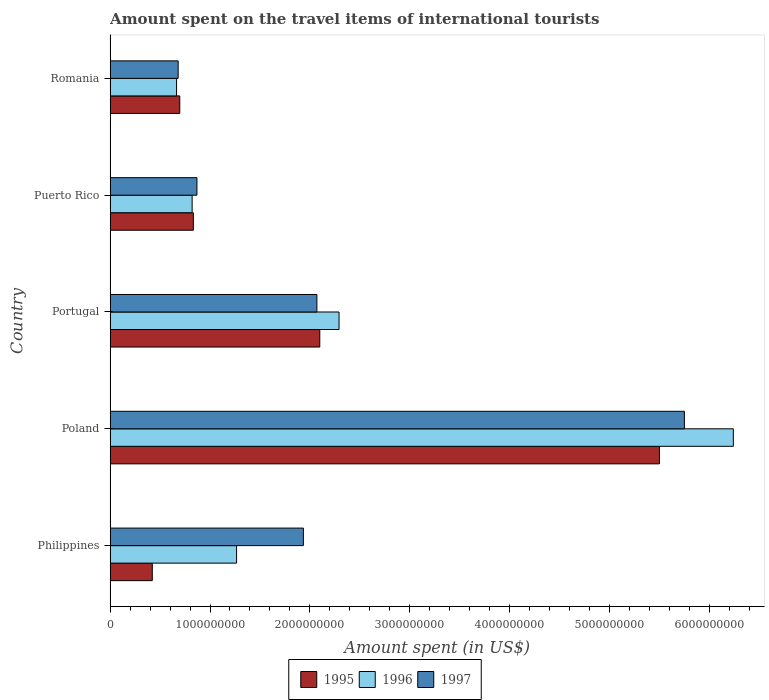How many different coloured bars are there?
Provide a succinct answer. 3. How many bars are there on the 5th tick from the top?
Your answer should be compact. 3. How many bars are there on the 3rd tick from the bottom?
Offer a very short reply. 3. In how many cases, is the number of bars for a given country not equal to the number of legend labels?
Give a very brief answer. 0. What is the amount spent on the travel items of international tourists in 1997 in Philippines?
Give a very brief answer. 1.94e+09. Across all countries, what is the maximum amount spent on the travel items of international tourists in 1997?
Offer a very short reply. 5.75e+09. Across all countries, what is the minimum amount spent on the travel items of international tourists in 1995?
Ensure brevity in your answer.  4.22e+08. In which country was the amount spent on the travel items of international tourists in 1995 maximum?
Make the answer very short. Poland. In which country was the amount spent on the travel items of international tourists in 1997 minimum?
Keep it short and to the point. Romania. What is the total amount spent on the travel items of international tourists in 1997 in the graph?
Ensure brevity in your answer.  1.13e+1. What is the difference between the amount spent on the travel items of international tourists in 1996 in Portugal and that in Romania?
Provide a short and direct response. 1.63e+09. What is the difference between the amount spent on the travel items of international tourists in 1995 in Romania and the amount spent on the travel items of international tourists in 1996 in Philippines?
Ensure brevity in your answer.  -5.69e+08. What is the average amount spent on the travel items of international tourists in 1996 per country?
Offer a very short reply. 2.26e+09. What is the difference between the amount spent on the travel items of international tourists in 1995 and amount spent on the travel items of international tourists in 1997 in Portugal?
Ensure brevity in your answer.  2.90e+07. What is the ratio of the amount spent on the travel items of international tourists in 1995 in Poland to that in Puerto Rico?
Offer a terse response. 6.6. Is the difference between the amount spent on the travel items of international tourists in 1995 in Portugal and Puerto Rico greater than the difference between the amount spent on the travel items of international tourists in 1997 in Portugal and Puerto Rico?
Ensure brevity in your answer.  Yes. What is the difference between the highest and the second highest amount spent on the travel items of international tourists in 1996?
Offer a very short reply. 3.95e+09. What is the difference between the highest and the lowest amount spent on the travel items of international tourists in 1995?
Keep it short and to the point. 5.08e+09. In how many countries, is the amount spent on the travel items of international tourists in 1997 greater than the average amount spent on the travel items of international tourists in 1997 taken over all countries?
Offer a terse response. 1. How many bars are there?
Ensure brevity in your answer.  15. Are all the bars in the graph horizontal?
Your response must be concise. Yes. Does the graph contain any zero values?
Offer a very short reply. No. Does the graph contain grids?
Your answer should be very brief. No. Where does the legend appear in the graph?
Offer a terse response. Bottom center. How many legend labels are there?
Your answer should be compact. 3. How are the legend labels stacked?
Offer a very short reply. Horizontal. What is the title of the graph?
Ensure brevity in your answer.  Amount spent on the travel items of international tourists. Does "2000" appear as one of the legend labels in the graph?
Your answer should be very brief. No. What is the label or title of the X-axis?
Offer a terse response. Amount spent (in US$). What is the label or title of the Y-axis?
Your answer should be very brief. Country. What is the Amount spent (in US$) of 1995 in Philippines?
Provide a short and direct response. 4.22e+08. What is the Amount spent (in US$) of 1996 in Philippines?
Keep it short and to the point. 1.27e+09. What is the Amount spent (in US$) of 1997 in Philippines?
Offer a very short reply. 1.94e+09. What is the Amount spent (in US$) of 1995 in Poland?
Provide a short and direct response. 5.50e+09. What is the Amount spent (in US$) of 1996 in Poland?
Your answer should be compact. 6.24e+09. What is the Amount spent (in US$) of 1997 in Poland?
Offer a very short reply. 5.75e+09. What is the Amount spent (in US$) of 1995 in Portugal?
Ensure brevity in your answer.  2.10e+09. What is the Amount spent (in US$) of 1996 in Portugal?
Offer a terse response. 2.29e+09. What is the Amount spent (in US$) of 1997 in Portugal?
Offer a terse response. 2.07e+09. What is the Amount spent (in US$) of 1995 in Puerto Rico?
Make the answer very short. 8.33e+08. What is the Amount spent (in US$) of 1996 in Puerto Rico?
Provide a succinct answer. 8.21e+08. What is the Amount spent (in US$) of 1997 in Puerto Rico?
Offer a very short reply. 8.69e+08. What is the Amount spent (in US$) in 1995 in Romania?
Keep it short and to the point. 6.97e+08. What is the Amount spent (in US$) in 1996 in Romania?
Your answer should be very brief. 6.65e+08. What is the Amount spent (in US$) of 1997 in Romania?
Make the answer very short. 6.81e+08. Across all countries, what is the maximum Amount spent (in US$) of 1995?
Your response must be concise. 5.50e+09. Across all countries, what is the maximum Amount spent (in US$) in 1996?
Your answer should be very brief. 6.24e+09. Across all countries, what is the maximum Amount spent (in US$) in 1997?
Your answer should be compact. 5.75e+09. Across all countries, what is the minimum Amount spent (in US$) in 1995?
Your response must be concise. 4.22e+08. Across all countries, what is the minimum Amount spent (in US$) in 1996?
Give a very brief answer. 6.65e+08. Across all countries, what is the minimum Amount spent (in US$) of 1997?
Provide a succinct answer. 6.81e+08. What is the total Amount spent (in US$) in 1995 in the graph?
Your answer should be compact. 9.55e+09. What is the total Amount spent (in US$) of 1996 in the graph?
Give a very brief answer. 1.13e+1. What is the total Amount spent (in US$) in 1997 in the graph?
Make the answer very short. 1.13e+1. What is the difference between the Amount spent (in US$) in 1995 in Philippines and that in Poland?
Your answer should be compact. -5.08e+09. What is the difference between the Amount spent (in US$) of 1996 in Philippines and that in Poland?
Your answer should be compact. -4.97e+09. What is the difference between the Amount spent (in US$) of 1997 in Philippines and that in Poland?
Offer a terse response. -3.82e+09. What is the difference between the Amount spent (in US$) of 1995 in Philippines and that in Portugal?
Offer a very short reply. -1.68e+09. What is the difference between the Amount spent (in US$) in 1996 in Philippines and that in Portugal?
Offer a terse response. -1.03e+09. What is the difference between the Amount spent (in US$) in 1997 in Philippines and that in Portugal?
Provide a short and direct response. -1.35e+08. What is the difference between the Amount spent (in US$) in 1995 in Philippines and that in Puerto Rico?
Your response must be concise. -4.11e+08. What is the difference between the Amount spent (in US$) of 1996 in Philippines and that in Puerto Rico?
Make the answer very short. 4.45e+08. What is the difference between the Amount spent (in US$) of 1997 in Philippines and that in Puerto Rico?
Your answer should be very brief. 1.07e+09. What is the difference between the Amount spent (in US$) of 1995 in Philippines and that in Romania?
Your answer should be compact. -2.75e+08. What is the difference between the Amount spent (in US$) of 1996 in Philippines and that in Romania?
Your answer should be compact. 6.01e+08. What is the difference between the Amount spent (in US$) in 1997 in Philippines and that in Romania?
Ensure brevity in your answer.  1.25e+09. What is the difference between the Amount spent (in US$) of 1995 in Poland and that in Portugal?
Provide a short and direct response. 3.40e+09. What is the difference between the Amount spent (in US$) in 1996 in Poland and that in Portugal?
Make the answer very short. 3.95e+09. What is the difference between the Amount spent (in US$) in 1997 in Poland and that in Portugal?
Your answer should be compact. 3.68e+09. What is the difference between the Amount spent (in US$) of 1995 in Poland and that in Puerto Rico?
Give a very brief answer. 4.67e+09. What is the difference between the Amount spent (in US$) of 1996 in Poland and that in Puerto Rico?
Offer a very short reply. 5.42e+09. What is the difference between the Amount spent (in US$) of 1997 in Poland and that in Puerto Rico?
Your answer should be compact. 4.88e+09. What is the difference between the Amount spent (in US$) in 1995 in Poland and that in Romania?
Keep it short and to the point. 4.80e+09. What is the difference between the Amount spent (in US$) of 1996 in Poland and that in Romania?
Make the answer very short. 5.58e+09. What is the difference between the Amount spent (in US$) in 1997 in Poland and that in Romania?
Your answer should be very brief. 5.07e+09. What is the difference between the Amount spent (in US$) of 1995 in Portugal and that in Puerto Rico?
Offer a very short reply. 1.27e+09. What is the difference between the Amount spent (in US$) in 1996 in Portugal and that in Puerto Rico?
Your response must be concise. 1.47e+09. What is the difference between the Amount spent (in US$) of 1997 in Portugal and that in Puerto Rico?
Provide a succinct answer. 1.20e+09. What is the difference between the Amount spent (in US$) in 1995 in Portugal and that in Romania?
Offer a terse response. 1.40e+09. What is the difference between the Amount spent (in US$) in 1996 in Portugal and that in Romania?
Your response must be concise. 1.63e+09. What is the difference between the Amount spent (in US$) of 1997 in Portugal and that in Romania?
Ensure brevity in your answer.  1.39e+09. What is the difference between the Amount spent (in US$) of 1995 in Puerto Rico and that in Romania?
Your response must be concise. 1.36e+08. What is the difference between the Amount spent (in US$) of 1996 in Puerto Rico and that in Romania?
Make the answer very short. 1.56e+08. What is the difference between the Amount spent (in US$) of 1997 in Puerto Rico and that in Romania?
Provide a short and direct response. 1.88e+08. What is the difference between the Amount spent (in US$) in 1995 in Philippines and the Amount spent (in US$) in 1996 in Poland?
Provide a succinct answer. -5.82e+09. What is the difference between the Amount spent (in US$) in 1995 in Philippines and the Amount spent (in US$) in 1997 in Poland?
Ensure brevity in your answer.  -5.33e+09. What is the difference between the Amount spent (in US$) of 1996 in Philippines and the Amount spent (in US$) of 1997 in Poland?
Ensure brevity in your answer.  -4.48e+09. What is the difference between the Amount spent (in US$) of 1995 in Philippines and the Amount spent (in US$) of 1996 in Portugal?
Your response must be concise. -1.87e+09. What is the difference between the Amount spent (in US$) in 1995 in Philippines and the Amount spent (in US$) in 1997 in Portugal?
Provide a succinct answer. -1.65e+09. What is the difference between the Amount spent (in US$) in 1996 in Philippines and the Amount spent (in US$) in 1997 in Portugal?
Your answer should be compact. -8.04e+08. What is the difference between the Amount spent (in US$) of 1995 in Philippines and the Amount spent (in US$) of 1996 in Puerto Rico?
Provide a short and direct response. -3.99e+08. What is the difference between the Amount spent (in US$) in 1995 in Philippines and the Amount spent (in US$) in 1997 in Puerto Rico?
Provide a succinct answer. -4.47e+08. What is the difference between the Amount spent (in US$) of 1996 in Philippines and the Amount spent (in US$) of 1997 in Puerto Rico?
Provide a succinct answer. 3.97e+08. What is the difference between the Amount spent (in US$) of 1995 in Philippines and the Amount spent (in US$) of 1996 in Romania?
Provide a short and direct response. -2.43e+08. What is the difference between the Amount spent (in US$) in 1995 in Philippines and the Amount spent (in US$) in 1997 in Romania?
Offer a very short reply. -2.59e+08. What is the difference between the Amount spent (in US$) in 1996 in Philippines and the Amount spent (in US$) in 1997 in Romania?
Your answer should be compact. 5.85e+08. What is the difference between the Amount spent (in US$) in 1995 in Poland and the Amount spent (in US$) in 1996 in Portugal?
Your answer should be compact. 3.21e+09. What is the difference between the Amount spent (in US$) in 1995 in Poland and the Amount spent (in US$) in 1997 in Portugal?
Provide a succinct answer. 3.43e+09. What is the difference between the Amount spent (in US$) in 1996 in Poland and the Amount spent (in US$) in 1997 in Portugal?
Your answer should be very brief. 4.17e+09. What is the difference between the Amount spent (in US$) of 1995 in Poland and the Amount spent (in US$) of 1996 in Puerto Rico?
Your answer should be very brief. 4.68e+09. What is the difference between the Amount spent (in US$) in 1995 in Poland and the Amount spent (in US$) in 1997 in Puerto Rico?
Keep it short and to the point. 4.63e+09. What is the difference between the Amount spent (in US$) in 1996 in Poland and the Amount spent (in US$) in 1997 in Puerto Rico?
Provide a short and direct response. 5.37e+09. What is the difference between the Amount spent (in US$) of 1995 in Poland and the Amount spent (in US$) of 1996 in Romania?
Give a very brief answer. 4.84e+09. What is the difference between the Amount spent (in US$) of 1995 in Poland and the Amount spent (in US$) of 1997 in Romania?
Provide a succinct answer. 4.82e+09. What is the difference between the Amount spent (in US$) in 1996 in Poland and the Amount spent (in US$) in 1997 in Romania?
Your answer should be compact. 5.56e+09. What is the difference between the Amount spent (in US$) in 1995 in Portugal and the Amount spent (in US$) in 1996 in Puerto Rico?
Offer a terse response. 1.28e+09. What is the difference between the Amount spent (in US$) of 1995 in Portugal and the Amount spent (in US$) of 1997 in Puerto Rico?
Your response must be concise. 1.23e+09. What is the difference between the Amount spent (in US$) in 1996 in Portugal and the Amount spent (in US$) in 1997 in Puerto Rico?
Make the answer very short. 1.42e+09. What is the difference between the Amount spent (in US$) of 1995 in Portugal and the Amount spent (in US$) of 1996 in Romania?
Offer a very short reply. 1.43e+09. What is the difference between the Amount spent (in US$) in 1995 in Portugal and the Amount spent (in US$) in 1997 in Romania?
Ensure brevity in your answer.  1.42e+09. What is the difference between the Amount spent (in US$) in 1996 in Portugal and the Amount spent (in US$) in 1997 in Romania?
Provide a short and direct response. 1.61e+09. What is the difference between the Amount spent (in US$) of 1995 in Puerto Rico and the Amount spent (in US$) of 1996 in Romania?
Your answer should be very brief. 1.68e+08. What is the difference between the Amount spent (in US$) of 1995 in Puerto Rico and the Amount spent (in US$) of 1997 in Romania?
Provide a short and direct response. 1.52e+08. What is the difference between the Amount spent (in US$) in 1996 in Puerto Rico and the Amount spent (in US$) in 1997 in Romania?
Ensure brevity in your answer.  1.40e+08. What is the average Amount spent (in US$) of 1995 per country?
Keep it short and to the point. 1.91e+09. What is the average Amount spent (in US$) in 1996 per country?
Give a very brief answer. 2.26e+09. What is the average Amount spent (in US$) of 1997 per country?
Keep it short and to the point. 2.26e+09. What is the difference between the Amount spent (in US$) in 1995 and Amount spent (in US$) in 1996 in Philippines?
Make the answer very short. -8.44e+08. What is the difference between the Amount spent (in US$) in 1995 and Amount spent (in US$) in 1997 in Philippines?
Your response must be concise. -1.51e+09. What is the difference between the Amount spent (in US$) of 1996 and Amount spent (in US$) of 1997 in Philippines?
Offer a very short reply. -6.69e+08. What is the difference between the Amount spent (in US$) in 1995 and Amount spent (in US$) in 1996 in Poland?
Your answer should be compact. -7.40e+08. What is the difference between the Amount spent (in US$) of 1995 and Amount spent (in US$) of 1997 in Poland?
Your answer should be compact. -2.50e+08. What is the difference between the Amount spent (in US$) of 1996 and Amount spent (in US$) of 1997 in Poland?
Your response must be concise. 4.90e+08. What is the difference between the Amount spent (in US$) of 1995 and Amount spent (in US$) of 1996 in Portugal?
Provide a short and direct response. -1.93e+08. What is the difference between the Amount spent (in US$) of 1995 and Amount spent (in US$) of 1997 in Portugal?
Provide a succinct answer. 2.90e+07. What is the difference between the Amount spent (in US$) in 1996 and Amount spent (in US$) in 1997 in Portugal?
Provide a short and direct response. 2.22e+08. What is the difference between the Amount spent (in US$) in 1995 and Amount spent (in US$) in 1996 in Puerto Rico?
Your answer should be very brief. 1.20e+07. What is the difference between the Amount spent (in US$) in 1995 and Amount spent (in US$) in 1997 in Puerto Rico?
Make the answer very short. -3.60e+07. What is the difference between the Amount spent (in US$) in 1996 and Amount spent (in US$) in 1997 in Puerto Rico?
Provide a short and direct response. -4.80e+07. What is the difference between the Amount spent (in US$) of 1995 and Amount spent (in US$) of 1996 in Romania?
Your answer should be compact. 3.20e+07. What is the difference between the Amount spent (in US$) of 1995 and Amount spent (in US$) of 1997 in Romania?
Keep it short and to the point. 1.60e+07. What is the difference between the Amount spent (in US$) of 1996 and Amount spent (in US$) of 1997 in Romania?
Make the answer very short. -1.60e+07. What is the ratio of the Amount spent (in US$) of 1995 in Philippines to that in Poland?
Your answer should be compact. 0.08. What is the ratio of the Amount spent (in US$) in 1996 in Philippines to that in Poland?
Ensure brevity in your answer.  0.2. What is the ratio of the Amount spent (in US$) of 1997 in Philippines to that in Poland?
Your response must be concise. 0.34. What is the ratio of the Amount spent (in US$) in 1995 in Philippines to that in Portugal?
Your response must be concise. 0.2. What is the ratio of the Amount spent (in US$) of 1996 in Philippines to that in Portugal?
Your answer should be very brief. 0.55. What is the ratio of the Amount spent (in US$) in 1997 in Philippines to that in Portugal?
Your response must be concise. 0.93. What is the ratio of the Amount spent (in US$) of 1995 in Philippines to that in Puerto Rico?
Give a very brief answer. 0.51. What is the ratio of the Amount spent (in US$) of 1996 in Philippines to that in Puerto Rico?
Your answer should be compact. 1.54. What is the ratio of the Amount spent (in US$) of 1997 in Philippines to that in Puerto Rico?
Your answer should be compact. 2.23. What is the ratio of the Amount spent (in US$) of 1995 in Philippines to that in Romania?
Provide a succinct answer. 0.61. What is the ratio of the Amount spent (in US$) of 1996 in Philippines to that in Romania?
Your response must be concise. 1.9. What is the ratio of the Amount spent (in US$) in 1997 in Philippines to that in Romania?
Your response must be concise. 2.84. What is the ratio of the Amount spent (in US$) in 1995 in Poland to that in Portugal?
Your answer should be compact. 2.62. What is the ratio of the Amount spent (in US$) of 1996 in Poland to that in Portugal?
Keep it short and to the point. 2.72. What is the ratio of the Amount spent (in US$) of 1997 in Poland to that in Portugal?
Offer a very short reply. 2.78. What is the ratio of the Amount spent (in US$) of 1995 in Poland to that in Puerto Rico?
Provide a short and direct response. 6.6. What is the ratio of the Amount spent (in US$) in 1996 in Poland to that in Puerto Rico?
Your answer should be very brief. 7.6. What is the ratio of the Amount spent (in US$) of 1997 in Poland to that in Puerto Rico?
Give a very brief answer. 6.62. What is the ratio of the Amount spent (in US$) of 1995 in Poland to that in Romania?
Your answer should be very brief. 7.89. What is the ratio of the Amount spent (in US$) in 1996 in Poland to that in Romania?
Your answer should be compact. 9.38. What is the ratio of the Amount spent (in US$) of 1997 in Poland to that in Romania?
Your answer should be compact. 8.44. What is the ratio of the Amount spent (in US$) in 1995 in Portugal to that in Puerto Rico?
Your response must be concise. 2.52. What is the ratio of the Amount spent (in US$) of 1996 in Portugal to that in Puerto Rico?
Your answer should be compact. 2.79. What is the ratio of the Amount spent (in US$) of 1997 in Portugal to that in Puerto Rico?
Ensure brevity in your answer.  2.38. What is the ratio of the Amount spent (in US$) of 1995 in Portugal to that in Romania?
Make the answer very short. 3.01. What is the ratio of the Amount spent (in US$) of 1996 in Portugal to that in Romania?
Give a very brief answer. 3.45. What is the ratio of the Amount spent (in US$) of 1997 in Portugal to that in Romania?
Give a very brief answer. 3.04. What is the ratio of the Amount spent (in US$) in 1995 in Puerto Rico to that in Romania?
Keep it short and to the point. 1.2. What is the ratio of the Amount spent (in US$) in 1996 in Puerto Rico to that in Romania?
Offer a very short reply. 1.23. What is the ratio of the Amount spent (in US$) of 1997 in Puerto Rico to that in Romania?
Offer a very short reply. 1.28. What is the difference between the highest and the second highest Amount spent (in US$) of 1995?
Offer a very short reply. 3.40e+09. What is the difference between the highest and the second highest Amount spent (in US$) of 1996?
Provide a short and direct response. 3.95e+09. What is the difference between the highest and the second highest Amount spent (in US$) in 1997?
Provide a succinct answer. 3.68e+09. What is the difference between the highest and the lowest Amount spent (in US$) in 1995?
Provide a succinct answer. 5.08e+09. What is the difference between the highest and the lowest Amount spent (in US$) in 1996?
Provide a succinct answer. 5.58e+09. What is the difference between the highest and the lowest Amount spent (in US$) in 1997?
Your response must be concise. 5.07e+09. 